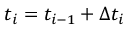<formula> <loc_0><loc_0><loc_500><loc_500>t _ { i } = t _ { i - 1 } + \Delta t _ { i }</formula> 